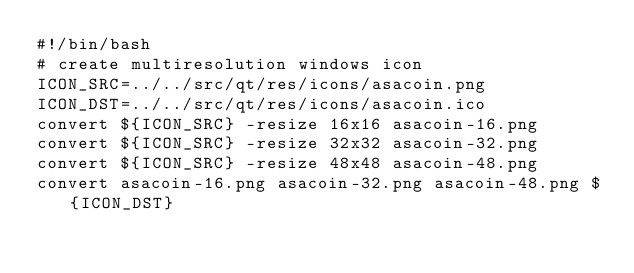<code> <loc_0><loc_0><loc_500><loc_500><_Bash_>#!/bin/bash
# create multiresolution windows icon
ICON_SRC=../../src/qt/res/icons/asacoin.png
ICON_DST=../../src/qt/res/icons/asacoin.ico
convert ${ICON_SRC} -resize 16x16 asacoin-16.png
convert ${ICON_SRC} -resize 32x32 asacoin-32.png
convert ${ICON_SRC} -resize 48x48 asacoin-48.png
convert asacoin-16.png asacoin-32.png asacoin-48.png ${ICON_DST}

</code> 